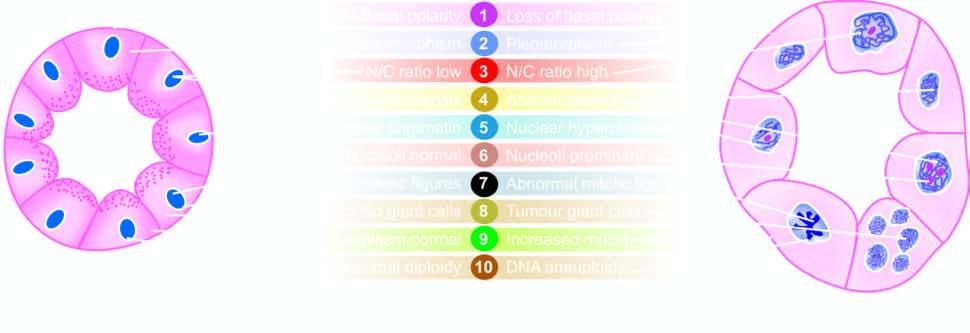what are contrasted with the appearance of an acinus a?
Answer the question using a single word or phrase. Characteristics of cancer in a gland 